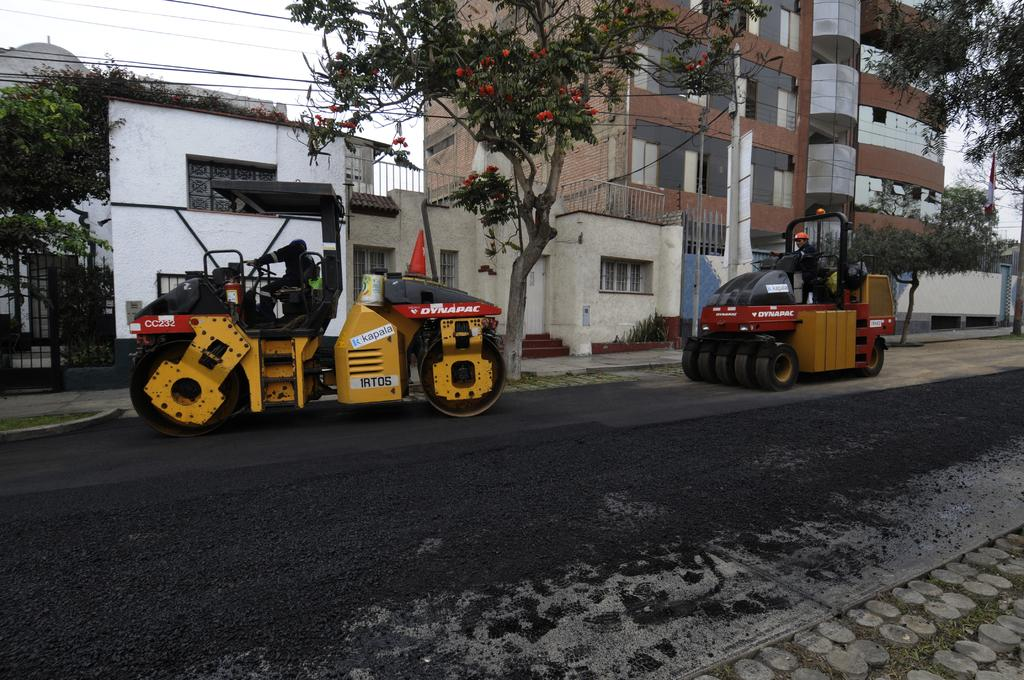What are the two people in the image doing? The two people are riding vehicles on the road. What can be seen in the background of the image? There are houses, buildings, plants, trees, a grill, wires, poles, a banner, and the sky visible in the background. What type of lumber is being used to construct the window in the image? There is no window present in the image, so it is not possible to determine what type of lumber might be used. 